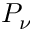Convert formula to latex. <formula><loc_0><loc_0><loc_500><loc_500>P _ { \nu }</formula> 